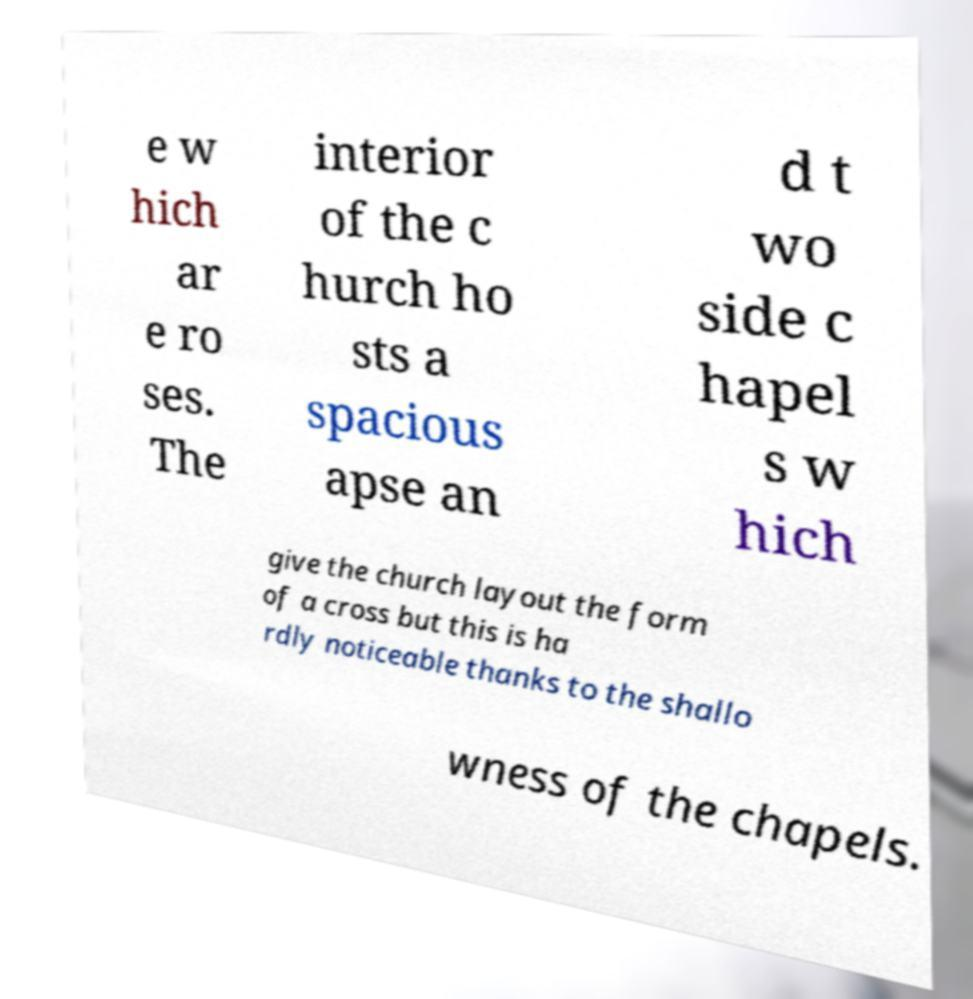Can you accurately transcribe the text from the provided image for me? e w hich ar e ro ses. The interior of the c hurch ho sts a spacious apse an d t wo side c hapel s w hich give the church layout the form of a cross but this is ha rdly noticeable thanks to the shallo wness of the chapels. 